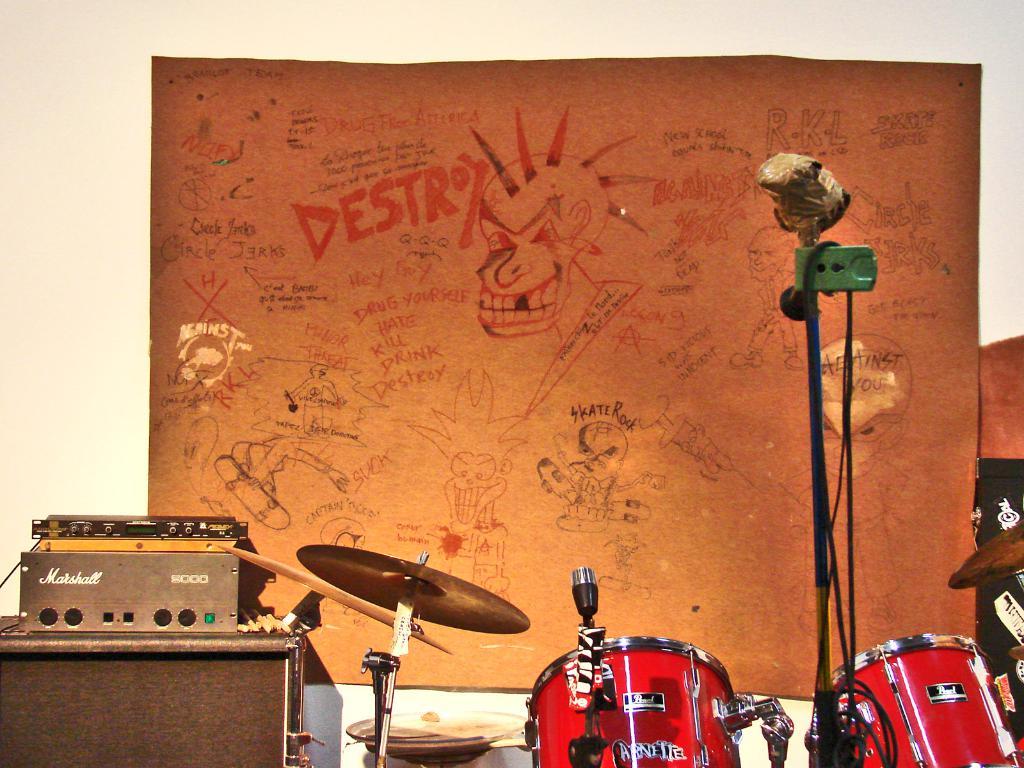What kind of amp is that?
Your answer should be compact. Marshall. Is the word "destroy" on this poster?
Your response must be concise. Yes. 